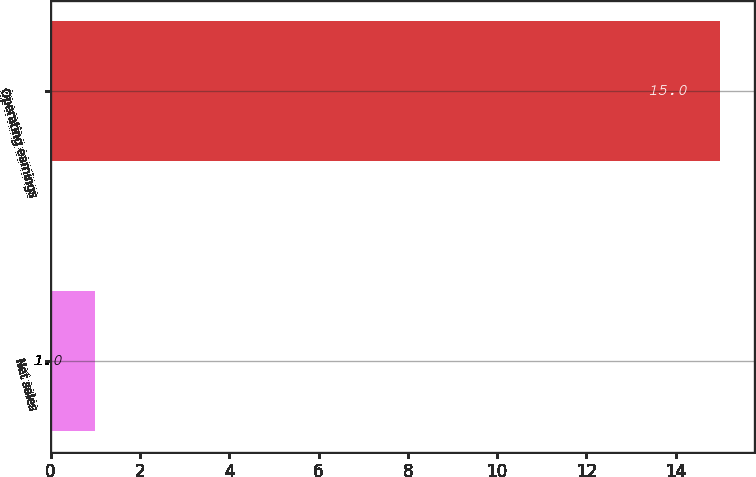Convert chart. <chart><loc_0><loc_0><loc_500><loc_500><bar_chart><fcel>Net sales<fcel>Operating earnings<nl><fcel>1<fcel>15<nl></chart> 